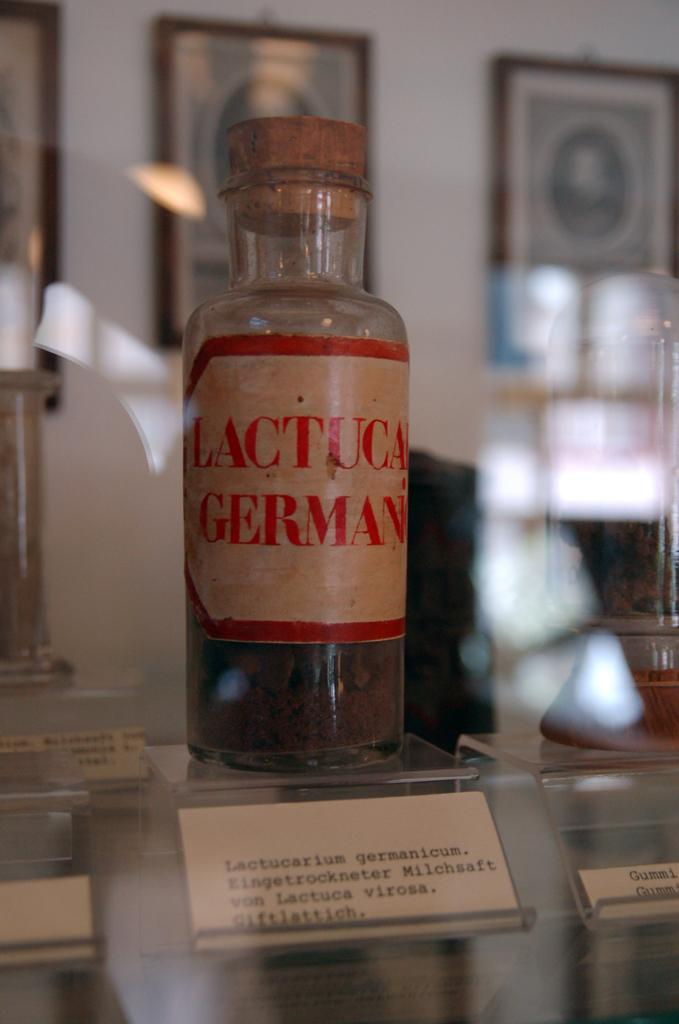<image>
Write a terse but informative summary of the picture. An old spice called Lactuca Germanicum sits on display 